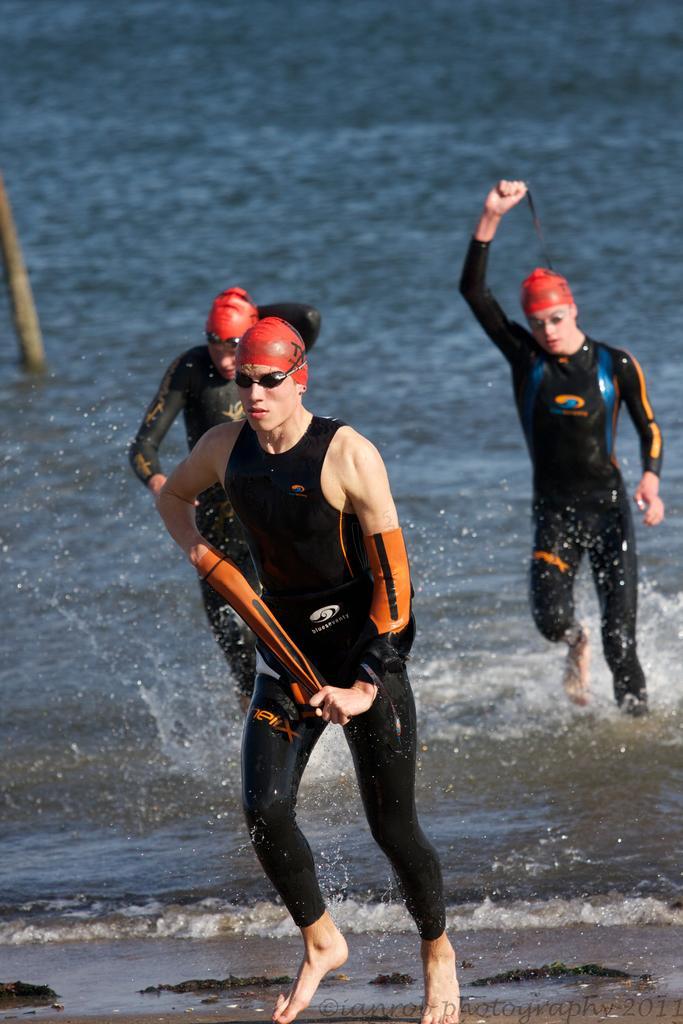Can you describe this image briefly? In this picture I can observe three members. All of them are wearing spectacles. In the background I can observe an ocean. 